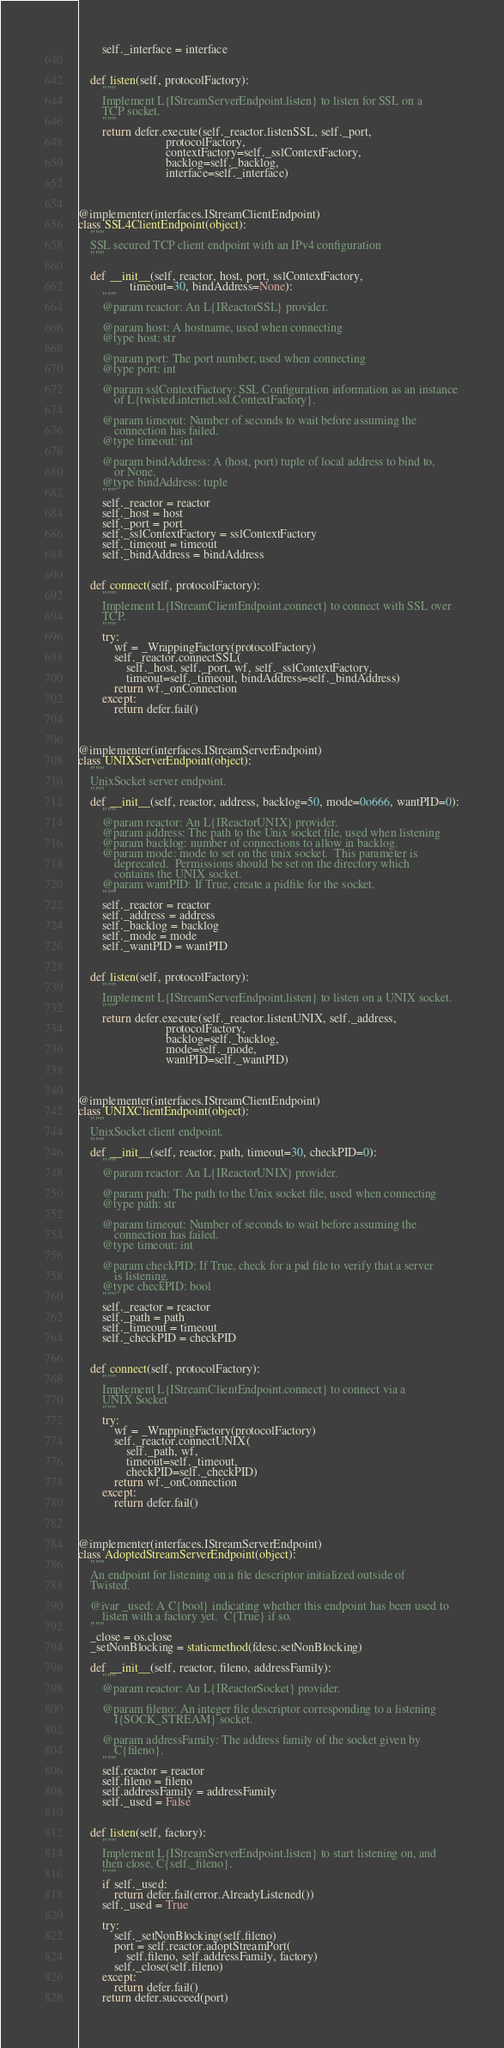<code> <loc_0><loc_0><loc_500><loc_500><_Python_>        self._interface = interface


    def listen(self, protocolFactory):
        """
        Implement L{IStreamServerEndpoint.listen} to listen for SSL on a
        TCP socket.
        """
        return defer.execute(self._reactor.listenSSL, self._port,
                             protocolFactory,
                             contextFactory=self._sslContextFactory,
                             backlog=self._backlog,
                             interface=self._interface)



@implementer(interfaces.IStreamClientEndpoint)
class SSL4ClientEndpoint(object):
    """
    SSL secured TCP client endpoint with an IPv4 configuration
    """

    def __init__(self, reactor, host, port, sslContextFactory,
                 timeout=30, bindAddress=None):
        """
        @param reactor: An L{IReactorSSL} provider.

        @param host: A hostname, used when connecting
        @type host: str

        @param port: The port number, used when connecting
        @type port: int

        @param sslContextFactory: SSL Configuration information as an instance
            of L{twisted.internet.ssl.ContextFactory}.

        @param timeout: Number of seconds to wait before assuming the
            connection has failed.
        @type timeout: int

        @param bindAddress: A (host, port) tuple of local address to bind to,
            or None.
        @type bindAddress: tuple
        """
        self._reactor = reactor
        self._host = host
        self._port = port
        self._sslContextFactory = sslContextFactory
        self._timeout = timeout
        self._bindAddress = bindAddress


    def connect(self, protocolFactory):
        """
        Implement L{IStreamClientEndpoint.connect} to connect with SSL over
        TCP.
        """
        try:
            wf = _WrappingFactory(protocolFactory)
            self._reactor.connectSSL(
                self._host, self._port, wf, self._sslContextFactory,
                timeout=self._timeout, bindAddress=self._bindAddress)
            return wf._onConnection
        except:
            return defer.fail()



@implementer(interfaces.IStreamServerEndpoint)
class UNIXServerEndpoint(object):
    """
    UnixSocket server endpoint.
    """
    def __init__(self, reactor, address, backlog=50, mode=0o666, wantPID=0):
        """
        @param reactor: An L{IReactorUNIX} provider.
        @param address: The path to the Unix socket file, used when listening
        @param backlog: number of connections to allow in backlog.
        @param mode: mode to set on the unix socket.  This parameter is
            deprecated.  Permissions should be set on the directory which
            contains the UNIX socket.
        @param wantPID: If True, create a pidfile for the socket.
        """
        self._reactor = reactor
        self._address = address
        self._backlog = backlog
        self._mode = mode
        self._wantPID = wantPID


    def listen(self, protocolFactory):
        """
        Implement L{IStreamServerEndpoint.listen} to listen on a UNIX socket.
        """
        return defer.execute(self._reactor.listenUNIX, self._address,
                             protocolFactory,
                             backlog=self._backlog,
                             mode=self._mode,
                             wantPID=self._wantPID)



@implementer(interfaces.IStreamClientEndpoint)
class UNIXClientEndpoint(object):
    """
    UnixSocket client endpoint.
    """
    def __init__(self, reactor, path, timeout=30, checkPID=0):
        """
        @param reactor: An L{IReactorUNIX} provider.

        @param path: The path to the Unix socket file, used when connecting
        @type path: str

        @param timeout: Number of seconds to wait before assuming the
            connection has failed.
        @type timeout: int

        @param checkPID: If True, check for a pid file to verify that a server
            is listening.
        @type checkPID: bool
        """
        self._reactor = reactor
        self._path = path
        self._timeout = timeout
        self._checkPID = checkPID


    def connect(self, protocolFactory):
        """
        Implement L{IStreamClientEndpoint.connect} to connect via a
        UNIX Socket
        """
        try:
            wf = _WrappingFactory(protocolFactory)
            self._reactor.connectUNIX(
                self._path, wf,
                timeout=self._timeout,
                checkPID=self._checkPID)
            return wf._onConnection
        except:
            return defer.fail()



@implementer(interfaces.IStreamServerEndpoint)
class AdoptedStreamServerEndpoint(object):
    """
    An endpoint for listening on a file descriptor initialized outside of
    Twisted.

    @ivar _used: A C{bool} indicating whether this endpoint has been used to
        listen with a factory yet.  C{True} if so.
    """
    _close = os.close
    _setNonBlocking = staticmethod(fdesc.setNonBlocking)

    def __init__(self, reactor, fileno, addressFamily):
        """
        @param reactor: An L{IReactorSocket} provider.

        @param fileno: An integer file descriptor corresponding to a listening
            I{SOCK_STREAM} socket.

        @param addressFamily: The address family of the socket given by
            C{fileno}.
        """
        self.reactor = reactor
        self.fileno = fileno
        self.addressFamily = addressFamily
        self._used = False


    def listen(self, factory):
        """
        Implement L{IStreamServerEndpoint.listen} to start listening on, and
        then close, C{self._fileno}.
        """
        if self._used:
            return defer.fail(error.AlreadyListened())
        self._used = True

        try:
            self._setNonBlocking(self.fileno)
            port = self.reactor.adoptStreamPort(
                self.fileno, self.addressFamily, factory)
            self._close(self.fileno)
        except:
            return defer.fail()
        return defer.succeed(port)


</code> 